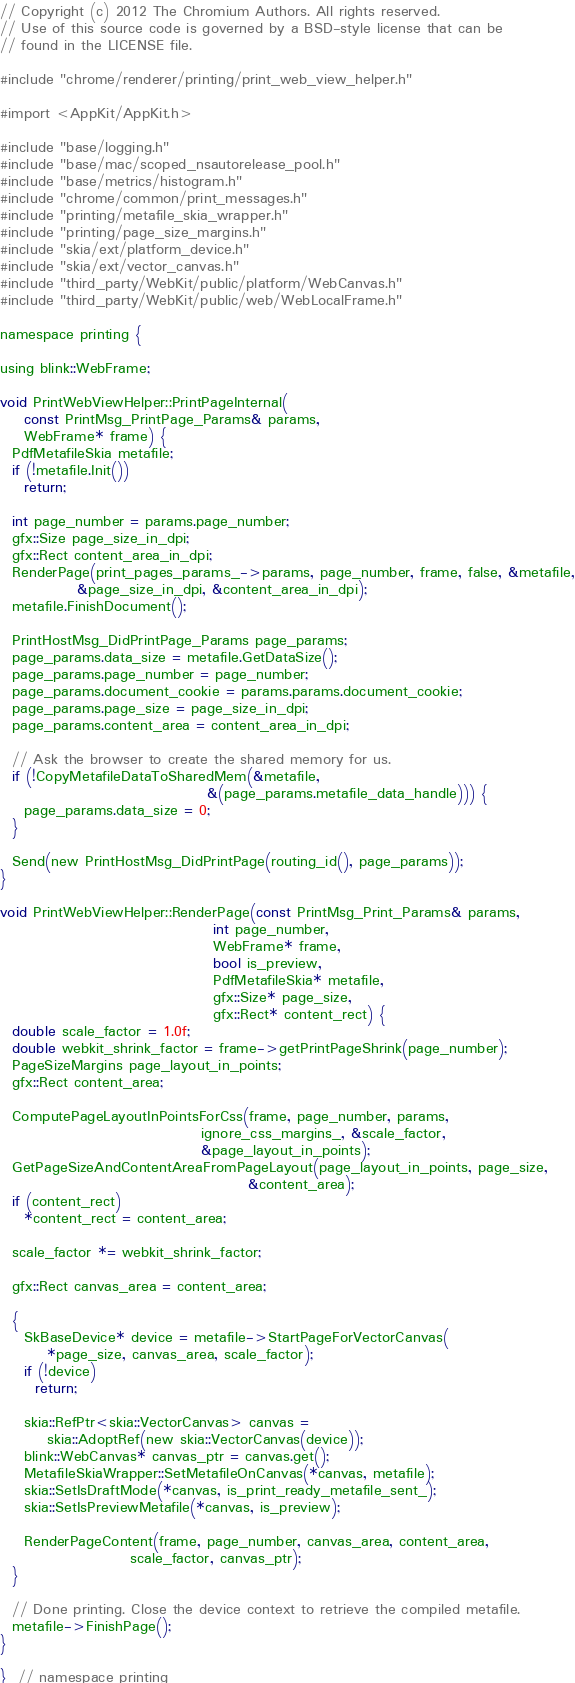<code> <loc_0><loc_0><loc_500><loc_500><_ObjectiveC_>// Copyright (c) 2012 The Chromium Authors. All rights reserved.
// Use of this source code is governed by a BSD-style license that can be
// found in the LICENSE file.

#include "chrome/renderer/printing/print_web_view_helper.h"

#import <AppKit/AppKit.h>

#include "base/logging.h"
#include "base/mac/scoped_nsautorelease_pool.h"
#include "base/metrics/histogram.h"
#include "chrome/common/print_messages.h"
#include "printing/metafile_skia_wrapper.h"
#include "printing/page_size_margins.h"
#include "skia/ext/platform_device.h"
#include "skia/ext/vector_canvas.h"
#include "third_party/WebKit/public/platform/WebCanvas.h"
#include "third_party/WebKit/public/web/WebLocalFrame.h"

namespace printing {

using blink::WebFrame;

void PrintWebViewHelper::PrintPageInternal(
    const PrintMsg_PrintPage_Params& params,
    WebFrame* frame) {
  PdfMetafileSkia metafile;
  if (!metafile.Init())
    return;

  int page_number = params.page_number;
  gfx::Size page_size_in_dpi;
  gfx::Rect content_area_in_dpi;
  RenderPage(print_pages_params_->params, page_number, frame, false, &metafile,
             &page_size_in_dpi, &content_area_in_dpi);
  metafile.FinishDocument();

  PrintHostMsg_DidPrintPage_Params page_params;
  page_params.data_size = metafile.GetDataSize();
  page_params.page_number = page_number;
  page_params.document_cookie = params.params.document_cookie;
  page_params.page_size = page_size_in_dpi;
  page_params.content_area = content_area_in_dpi;

  // Ask the browser to create the shared memory for us.
  if (!CopyMetafileDataToSharedMem(&metafile,
                                   &(page_params.metafile_data_handle))) {
    page_params.data_size = 0;
  }

  Send(new PrintHostMsg_DidPrintPage(routing_id(), page_params));
}

void PrintWebViewHelper::RenderPage(const PrintMsg_Print_Params& params,
                                    int page_number,
                                    WebFrame* frame,
                                    bool is_preview,
                                    PdfMetafileSkia* metafile,
                                    gfx::Size* page_size,
                                    gfx::Rect* content_rect) {
  double scale_factor = 1.0f;
  double webkit_shrink_factor = frame->getPrintPageShrink(page_number);
  PageSizeMargins page_layout_in_points;
  gfx::Rect content_area;

  ComputePageLayoutInPointsForCss(frame, page_number, params,
                                  ignore_css_margins_, &scale_factor,
                                  &page_layout_in_points);
  GetPageSizeAndContentAreaFromPageLayout(page_layout_in_points, page_size,
                                          &content_area);
  if (content_rect)
    *content_rect = content_area;

  scale_factor *= webkit_shrink_factor;

  gfx::Rect canvas_area = content_area;

  {
    SkBaseDevice* device = metafile->StartPageForVectorCanvas(
        *page_size, canvas_area, scale_factor);
    if (!device)
      return;

    skia::RefPtr<skia::VectorCanvas> canvas =
        skia::AdoptRef(new skia::VectorCanvas(device));
    blink::WebCanvas* canvas_ptr = canvas.get();
    MetafileSkiaWrapper::SetMetafileOnCanvas(*canvas, metafile);
    skia::SetIsDraftMode(*canvas, is_print_ready_metafile_sent_);
    skia::SetIsPreviewMetafile(*canvas, is_preview);

    RenderPageContent(frame, page_number, canvas_area, content_area,
                      scale_factor, canvas_ptr);
  }

  // Done printing. Close the device context to retrieve the compiled metafile.
  metafile->FinishPage();
}

}  // namespace printing
</code> 